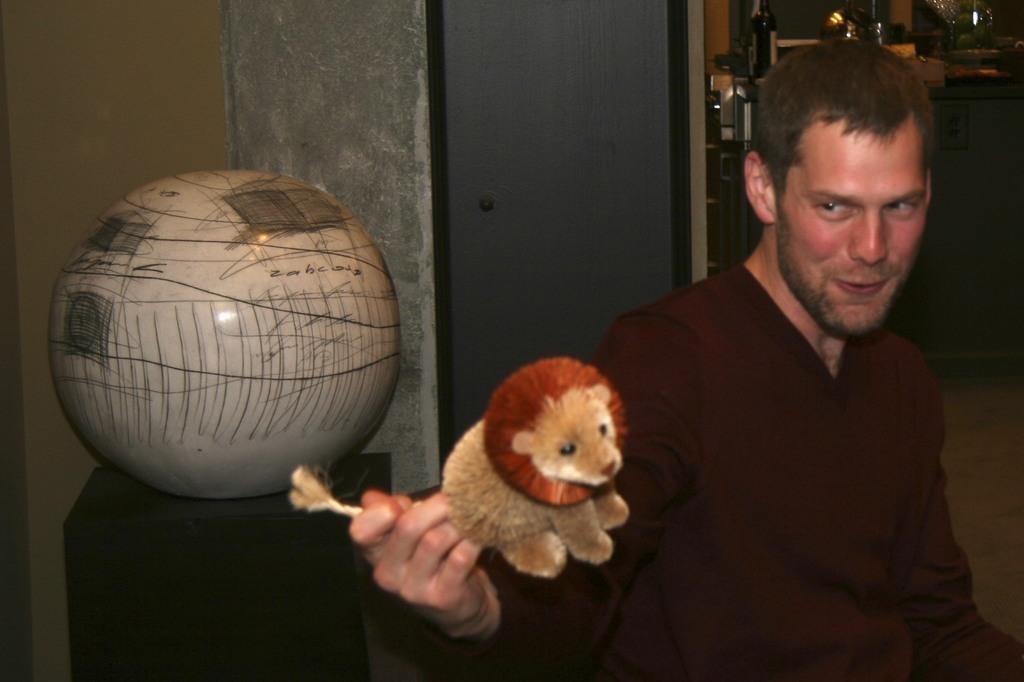In one or two sentences, can you explain what this image depicts? In this picture we can see a toy animal with his hand and smiling and at the back of him we can see a round object on a stand, wall and in the background we can see a bottle, lights and some objects. 